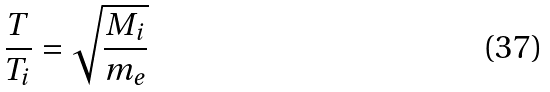Convert formula to latex. <formula><loc_0><loc_0><loc_500><loc_500>\frac { T } { T _ { i } } = \sqrt { \frac { M _ { i } } { m _ { e } } }</formula> 